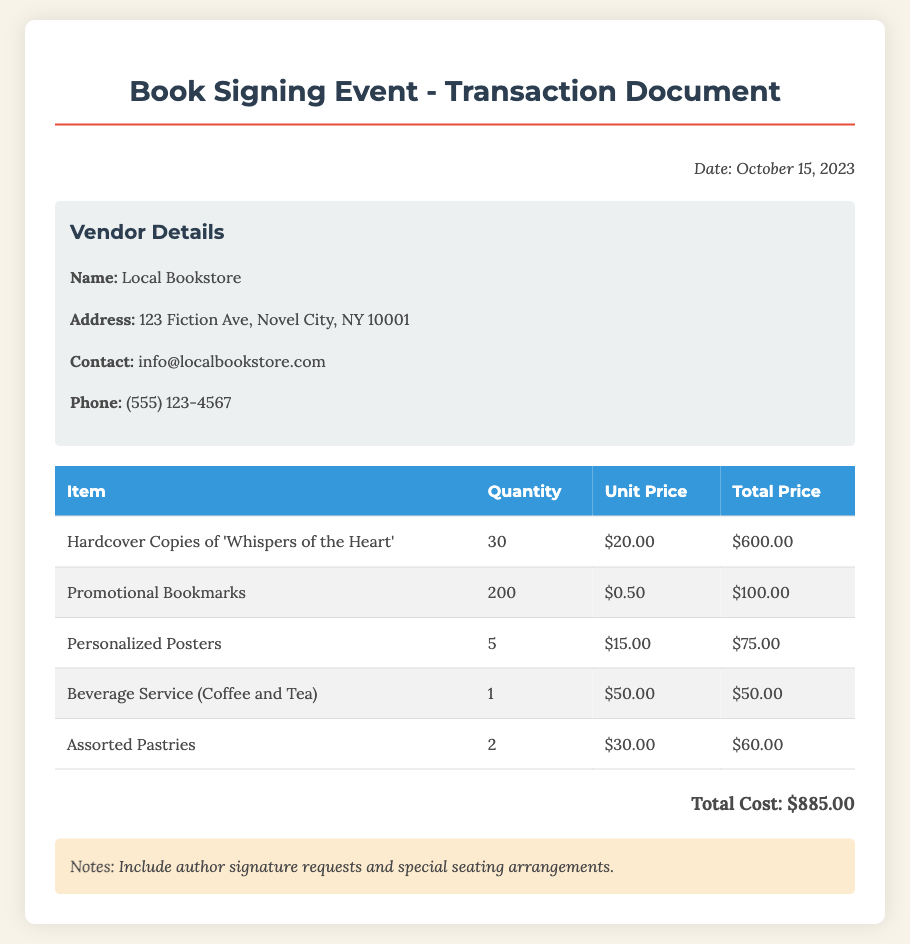what is the date of the event? The date of the event is clearly stated in the document.
Answer: October 15, 2023 what is the name of the vendor? The vendor's name is listed in the vendor details section of the document.
Answer: Local Bookstore how many hardcover copies of 'Whispers of the Heart' were purchased? The quantity of hardcover copies purchased is specified in the table of items.
Answer: 30 what is the total cost of the transaction? The total cost is summarized at the bottom of the document after all the item prices.
Answer: $885.00 how many promotional bookmarks were ordered? The quantity of promotional bookmarks is found in the list of purchased items.
Answer: 200 what is the unit price of the personalized posters? The unit price is provided in the table alongside the quantity and total price for personalized posters.
Answer: $15.00 what type of beverage service was included? The details about the beverage service are mentioned in the item list.
Answer: Coffee and Tea what is noted about author signatures? The notes section provides additional requests concerning the event.
Answer: Include author signature requests how many assorted pastries were ordered? The quantity of assorted pastries is visible in the purchase list.
Answer: 2 